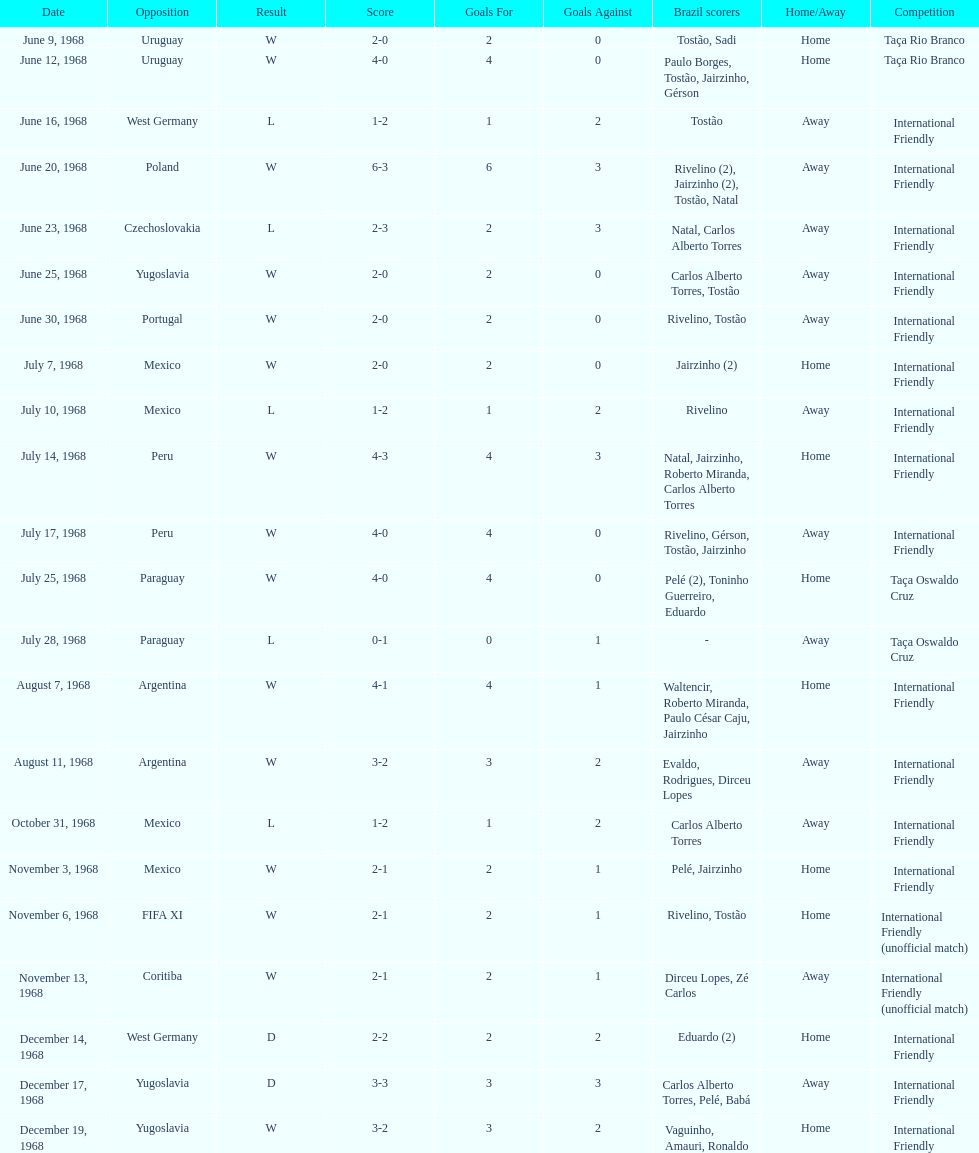The most goals scored by brazil in a game 6. 